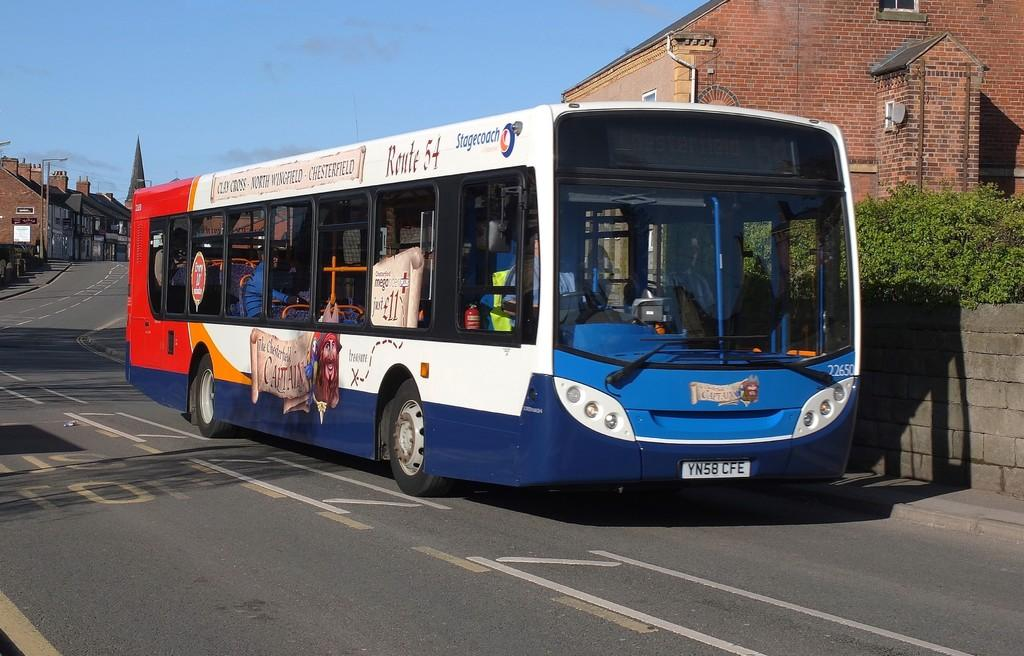<image>
Share a concise interpretation of the image provided. A bus on Route 54 waiting at the curb 